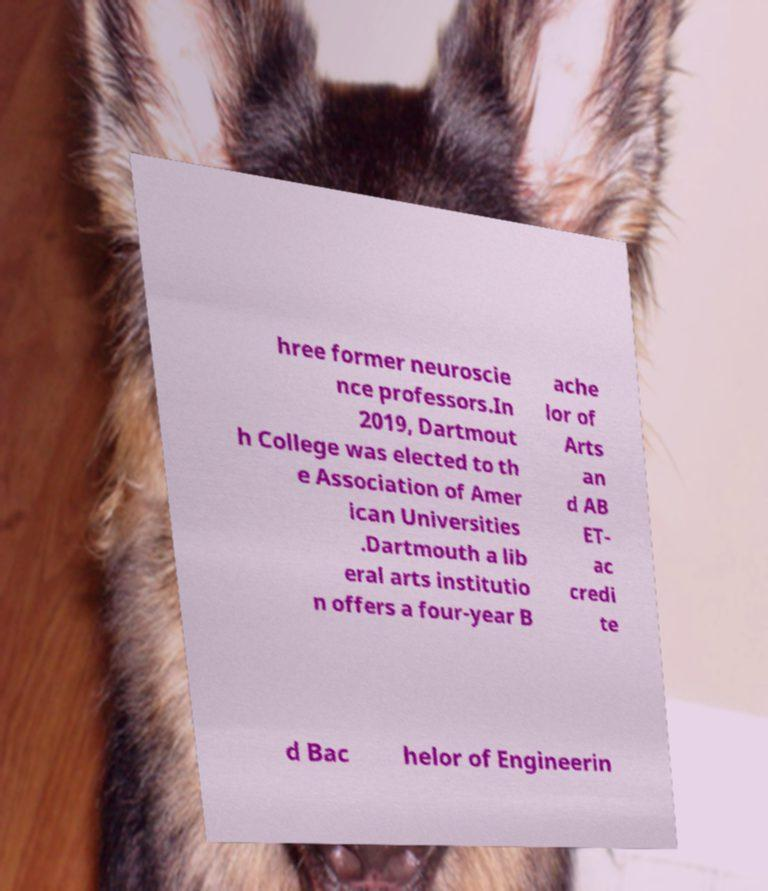Could you extract and type out the text from this image? hree former neuroscie nce professors.In 2019, Dartmout h College was elected to th e Association of Amer ican Universities .Dartmouth a lib eral arts institutio n offers a four-year B ache lor of Arts an d AB ET- ac credi te d Bac helor of Engineerin 